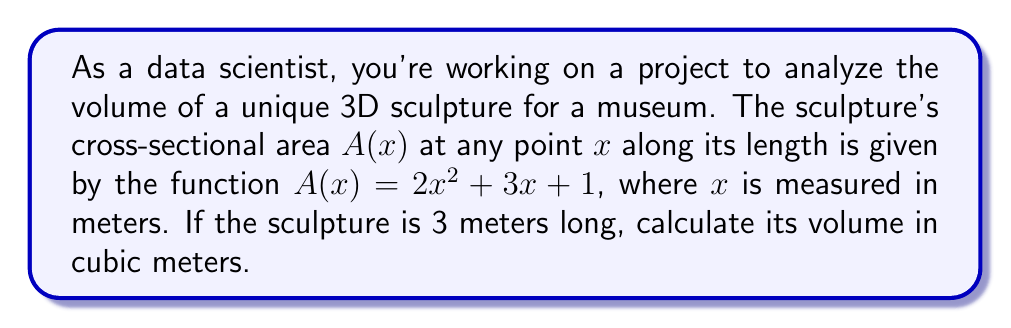Help me with this question. To calculate the volume of this irregular 3D shape, we'll use integration. The volume of a solid with variable cross-sectional area is given by the integral of the area function over the length of the solid.

1) The volume formula is:
   $$V = \int_a^b A(x) dx$$
   where $a$ and $b$ are the start and end points of the solid along the x-axis.

2) In this case, $a = 0$ and $b = 3$ (since the sculpture is 3 meters long), and $A(x) = 2x^2 + 3x + 1$.

3) Substituting these into our volume formula:
   $$V = \int_0^3 (2x^2 + 3x + 1) dx$$

4) Integrate the function:
   $$V = \left[\frac{2x^3}{3} + \frac{3x^2}{2} + x\right]_0^3$$

5) Evaluate the integral at the bounds:
   $$V = \left(\frac{2(3^3)}{3} + \frac{3(3^2)}{2} + 3\right) - \left(\frac{2(0^3)}{3} + \frac{3(0^2)}{2} + 0\right)$$

6) Simplify:
   $$V = (18 + 13.5 + 3) - 0 = 34.5$$

Therefore, the volume of the sculpture is 34.5 cubic meters.
Answer: 34.5 m³ 